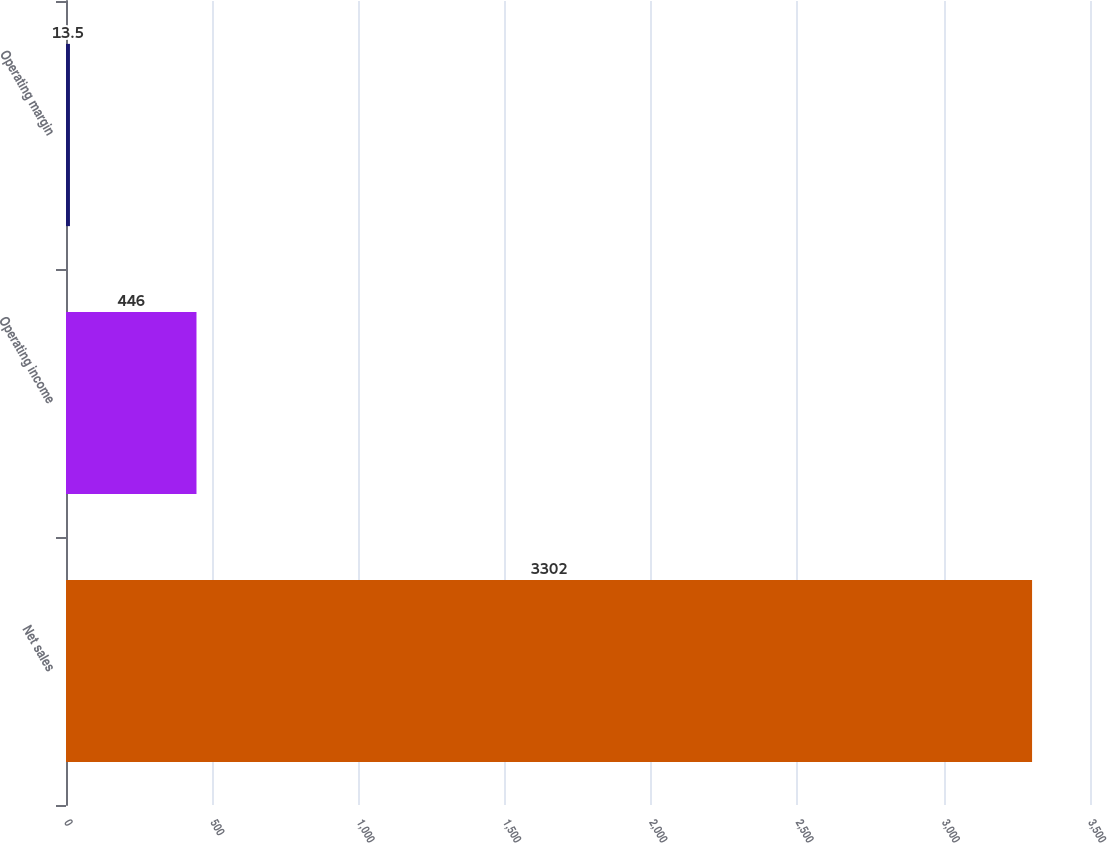Convert chart to OTSL. <chart><loc_0><loc_0><loc_500><loc_500><bar_chart><fcel>Net sales<fcel>Operating income<fcel>Operating margin<nl><fcel>3302<fcel>446<fcel>13.5<nl></chart> 